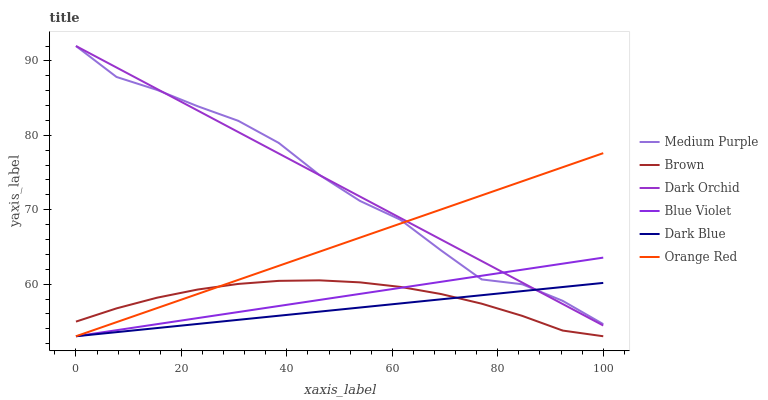Does Dark Blue have the minimum area under the curve?
Answer yes or no. Yes. Does Dark Orchid have the maximum area under the curve?
Answer yes or no. Yes. Does Medium Purple have the minimum area under the curve?
Answer yes or no. No. Does Medium Purple have the maximum area under the curve?
Answer yes or no. No. Is Dark Blue the smoothest?
Answer yes or no. Yes. Is Medium Purple the roughest?
Answer yes or no. Yes. Is Dark Orchid the smoothest?
Answer yes or no. No. Is Dark Orchid the roughest?
Answer yes or no. No. Does Brown have the lowest value?
Answer yes or no. Yes. Does Dark Orchid have the lowest value?
Answer yes or no. No. Does Medium Purple have the highest value?
Answer yes or no. Yes. Does Dark Blue have the highest value?
Answer yes or no. No. Is Brown less than Dark Orchid?
Answer yes or no. Yes. Is Medium Purple greater than Brown?
Answer yes or no. Yes. Does Blue Violet intersect Orange Red?
Answer yes or no. Yes. Is Blue Violet less than Orange Red?
Answer yes or no. No. Is Blue Violet greater than Orange Red?
Answer yes or no. No. Does Brown intersect Dark Orchid?
Answer yes or no. No. 